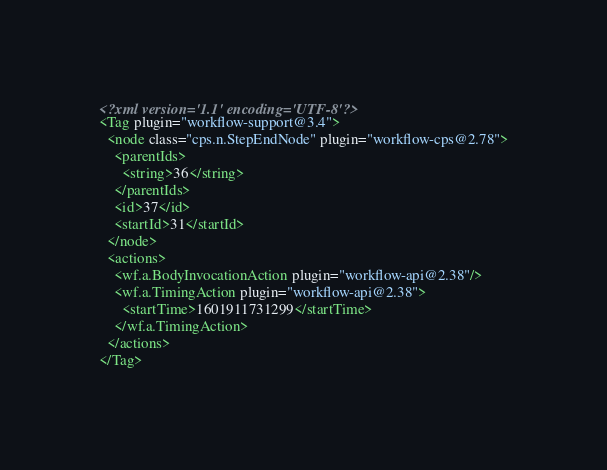<code> <loc_0><loc_0><loc_500><loc_500><_XML_><?xml version='1.1' encoding='UTF-8'?>
<Tag plugin="workflow-support@3.4">
  <node class="cps.n.StepEndNode" plugin="workflow-cps@2.78">
    <parentIds>
      <string>36</string>
    </parentIds>
    <id>37</id>
    <startId>31</startId>
  </node>
  <actions>
    <wf.a.BodyInvocationAction plugin="workflow-api@2.38"/>
    <wf.a.TimingAction plugin="workflow-api@2.38">
      <startTime>1601911731299</startTime>
    </wf.a.TimingAction>
  </actions>
</Tag></code> 